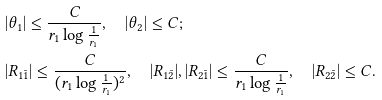<formula> <loc_0><loc_0><loc_500><loc_500>& | \theta _ { 1 } | \leq \frac { C } { r _ { 1 } \log \frac { 1 } { r _ { 1 } } } , \quad | \theta _ { 2 } | \leq C ; \\ & | R _ { 1 \bar { 1 } } | \leq \frac { C } { ( r _ { 1 } \log \frac { 1 } { r _ { 1 } } ) ^ { 2 } } , \quad | R _ { 1 \bar { 2 } } | , | R _ { 2 \bar { 1 } } | \leq \frac { C } { r _ { 1 } \log \frac { 1 } { r _ { 1 } } } , \quad | R _ { 2 \bar { 2 } } | \leq C .</formula> 